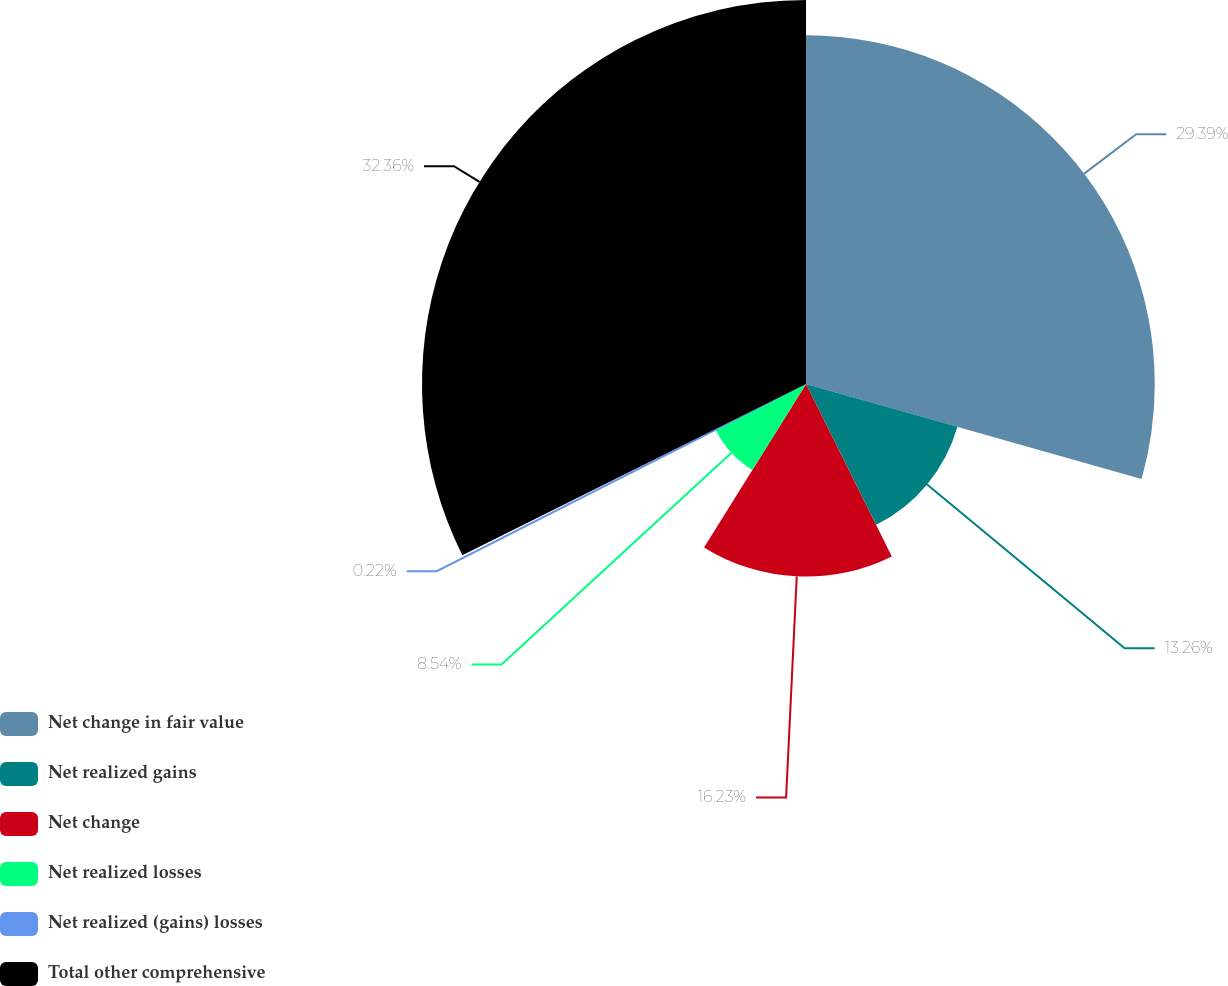Convert chart. <chart><loc_0><loc_0><loc_500><loc_500><pie_chart><fcel>Net change in fair value<fcel>Net realized gains<fcel>Net change<fcel>Net realized losses<fcel>Net realized (gains) losses<fcel>Total other comprehensive<nl><fcel>29.39%<fcel>13.26%<fcel>16.23%<fcel>8.54%<fcel>0.22%<fcel>32.36%<nl></chart> 